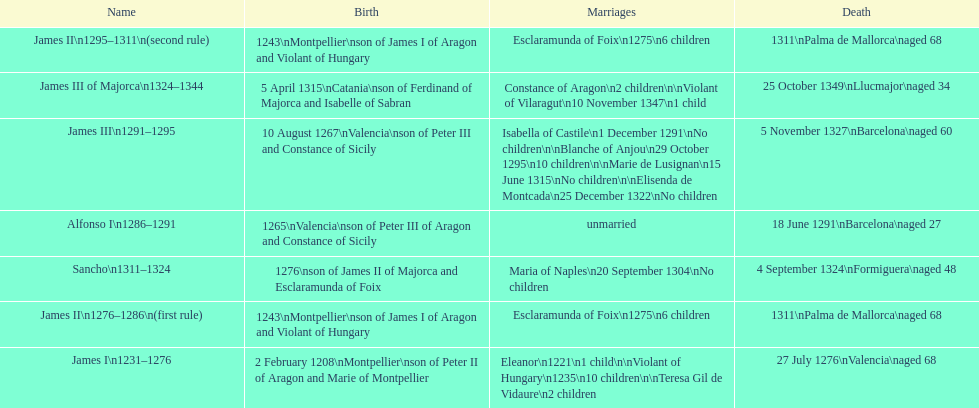James i and james ii both died at what age? 68. 